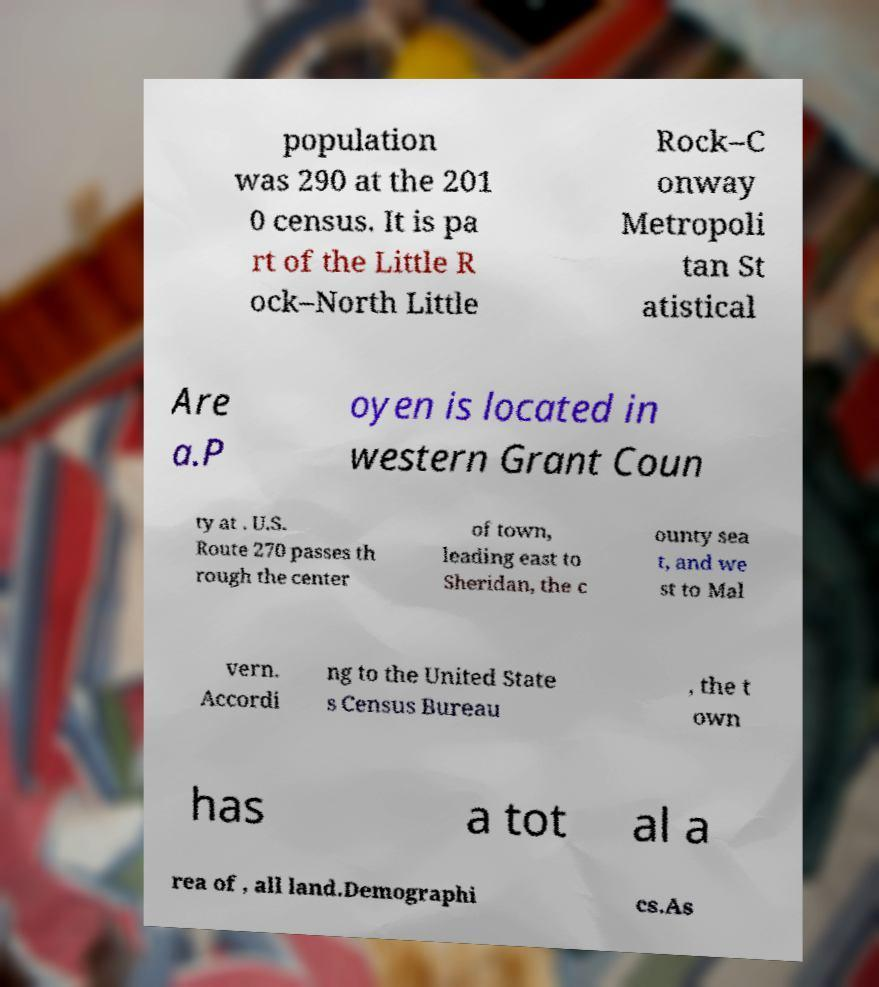Could you extract and type out the text from this image? population was 290 at the 201 0 census. It is pa rt of the Little R ock–North Little Rock–C onway Metropoli tan St atistical Are a.P oyen is located in western Grant Coun ty at . U.S. Route 270 passes th rough the center of town, leading east to Sheridan, the c ounty sea t, and we st to Mal vern. Accordi ng to the United State s Census Bureau , the t own has a tot al a rea of , all land.Demographi cs.As 